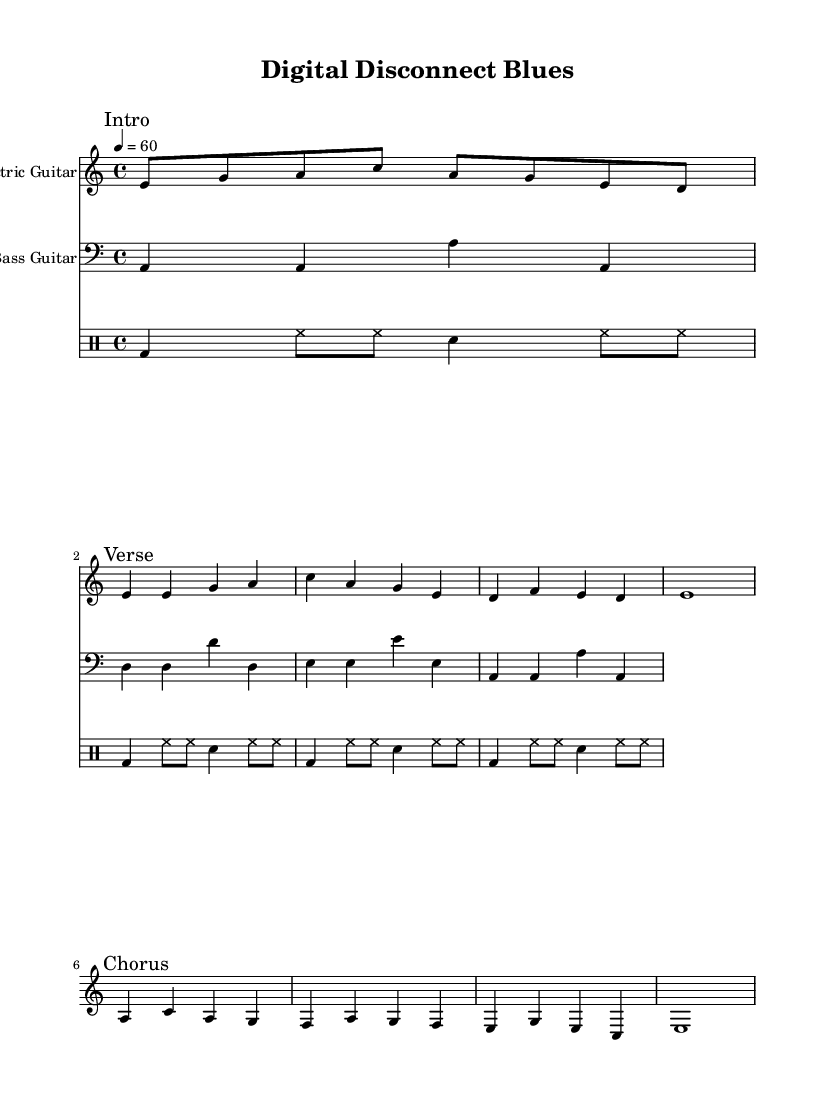What is the key signature of this music? The key signature is A minor, which has no sharps or flats.
Answer: A minor What is the time signature of this piece? The time signature is indicated as 4/4, meaning there are four beats in a measure and the quarter note gets one beat.
Answer: 4/4 What is the tempo of the music? The tempo marking indicates a speed of 60 beats per minute, which means one beat occurs every second.
Answer: 60 How many bars are in the verse section? The verse section consists of three measures, as indicated by the separation of the musical phrases.
Answer: 3 What instruments are featured in this score? The score includes an electric guitar, a bass guitar, and drums, which are all clearly indicated at the beginning of their respective staves.
Answer: Electric guitar, bass guitar, drums Which section of the music follows the intro? The section titled "Verse" comes immediately after the "Intro," revealing the structure of the piece.
Answer: Verse What characteristic does this music have that relates to the Electric Blues genre? The repetitive guitar riffs and emotional expression through simple chord progressions exemplify typical traits of Electric Blues music.
Answer: Repetitive guitar riffs 